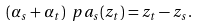Convert formula to latex. <formula><loc_0><loc_0><loc_500><loc_500>( \alpha _ { s } + \alpha _ { t } ) \ p a _ { s } ( z _ { t } ) = z _ { t } - z _ { s } .</formula> 